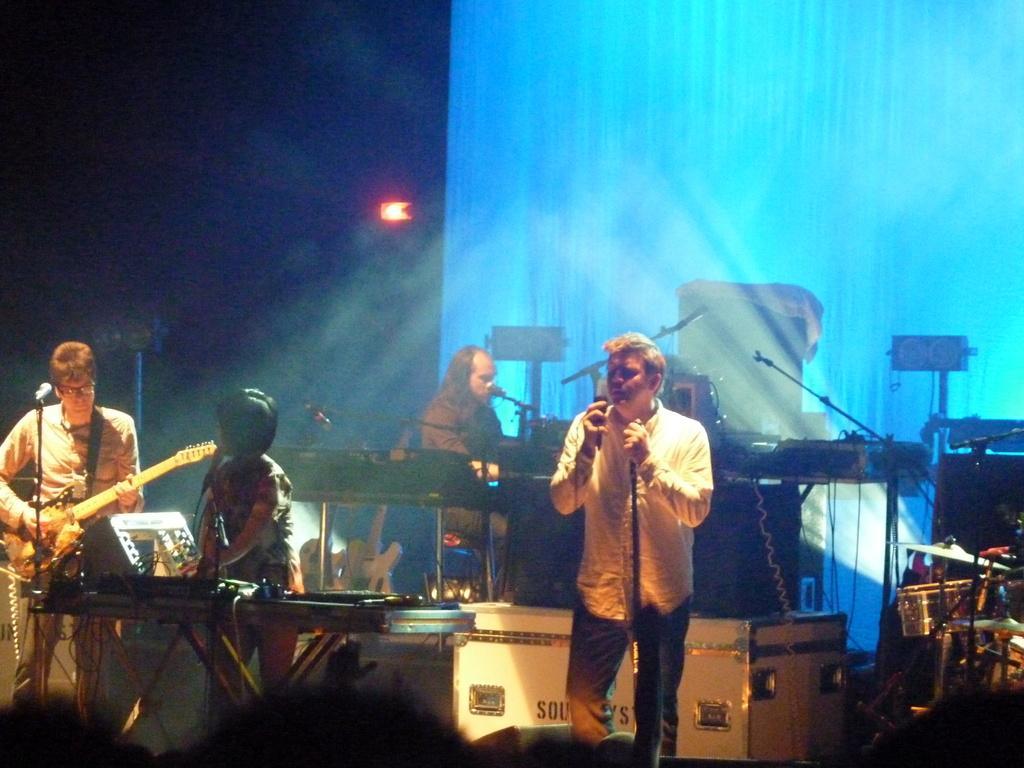Could you give a brief overview of what you see in this image? The picture contains there are 4 people 2 people are singing the song and 2 people are playing the guitars and background is very dark. 